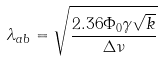<formula> <loc_0><loc_0><loc_500><loc_500>\lambda _ { a b } = \sqrt { \frac { 2 . 3 6 \Phi _ { 0 } \gamma \sqrt { k } } { \Delta \nu } }</formula> 